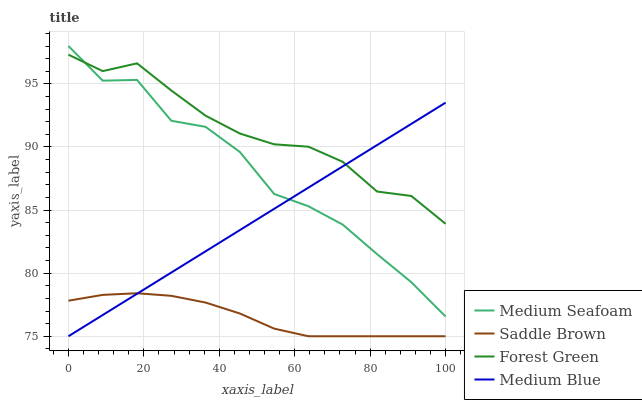Does Medium Blue have the minimum area under the curve?
Answer yes or no. No. Does Medium Blue have the maximum area under the curve?
Answer yes or no. No. Is Medium Seafoam the smoothest?
Answer yes or no. No. Is Medium Blue the roughest?
Answer yes or no. No. Does Medium Seafoam have the lowest value?
Answer yes or no. No. Does Medium Blue have the highest value?
Answer yes or no. No. Is Saddle Brown less than Medium Seafoam?
Answer yes or no. Yes. Is Forest Green greater than Saddle Brown?
Answer yes or no. Yes. Does Saddle Brown intersect Medium Seafoam?
Answer yes or no. No. 